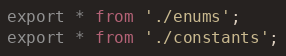Convert code to text. <code><loc_0><loc_0><loc_500><loc_500><_TypeScript_>export * from './enums';
export * from './constants';
</code> 